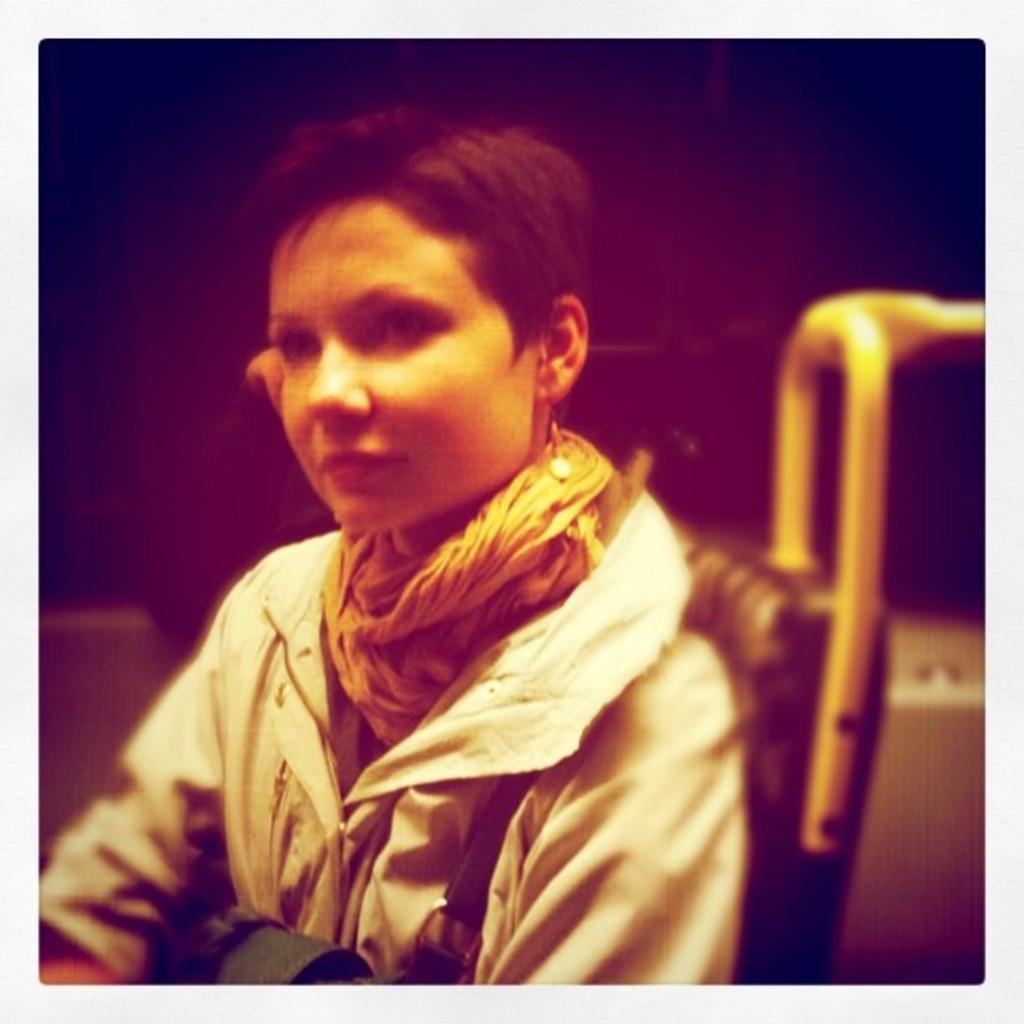What is the person in the image doing? The person is sitting in the image. What type of clothing is the person wearing? The person is wearing a coat and a stole. What type of oil can be seen dripping from the person's coat in the image? There is no oil present in the image, and the person's coat is not dripping. 